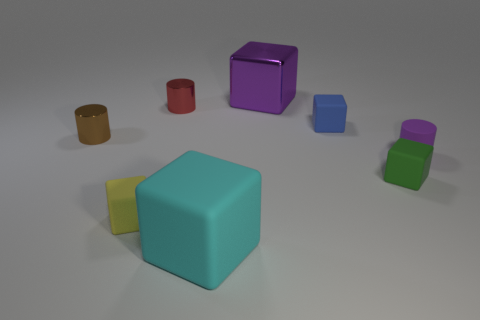Subtract all cyan rubber blocks. How many blocks are left? 4 Add 1 blocks. How many objects exist? 9 Subtract all purple cylinders. How many cylinders are left? 2 Subtract all brown cubes. Subtract all cyan cylinders. How many cubes are left? 5 Add 5 tiny green rubber cubes. How many tiny green rubber cubes are left? 6 Add 7 small purple cylinders. How many small purple cylinders exist? 8 Subtract 0 red blocks. How many objects are left? 8 Subtract all cylinders. How many objects are left? 5 Subtract all tiny cyan metallic blocks. Subtract all tiny objects. How many objects are left? 2 